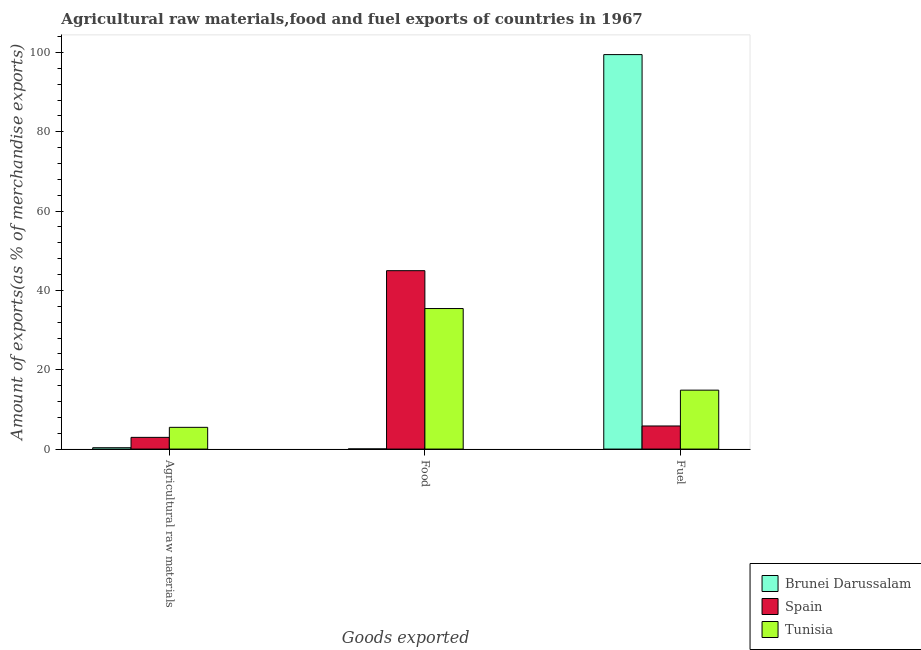How many different coloured bars are there?
Keep it short and to the point. 3. How many groups of bars are there?
Keep it short and to the point. 3. Are the number of bars per tick equal to the number of legend labels?
Your answer should be compact. Yes. How many bars are there on the 3rd tick from the left?
Provide a succinct answer. 3. How many bars are there on the 3rd tick from the right?
Your response must be concise. 3. What is the label of the 1st group of bars from the left?
Provide a succinct answer. Agricultural raw materials. What is the percentage of raw materials exports in Tunisia?
Ensure brevity in your answer.  5.48. Across all countries, what is the maximum percentage of raw materials exports?
Provide a succinct answer. 5.48. Across all countries, what is the minimum percentage of raw materials exports?
Ensure brevity in your answer.  0.34. In which country was the percentage of fuel exports maximum?
Offer a very short reply. Brunei Darussalam. What is the total percentage of raw materials exports in the graph?
Make the answer very short. 8.78. What is the difference between the percentage of raw materials exports in Spain and that in Tunisia?
Make the answer very short. -2.53. What is the difference between the percentage of fuel exports in Brunei Darussalam and the percentage of raw materials exports in Tunisia?
Your response must be concise. 93.98. What is the average percentage of raw materials exports per country?
Make the answer very short. 2.93. What is the difference between the percentage of raw materials exports and percentage of fuel exports in Spain?
Provide a short and direct response. -2.87. What is the ratio of the percentage of fuel exports in Brunei Darussalam to that in Spain?
Make the answer very short. 17.08. Is the percentage of food exports in Tunisia less than that in Brunei Darussalam?
Your answer should be compact. No. Is the difference between the percentage of raw materials exports in Spain and Brunei Darussalam greater than the difference between the percentage of fuel exports in Spain and Brunei Darussalam?
Ensure brevity in your answer.  Yes. What is the difference between the highest and the second highest percentage of fuel exports?
Your answer should be compact. 84.6. What is the difference between the highest and the lowest percentage of food exports?
Keep it short and to the point. 44.94. In how many countries, is the percentage of food exports greater than the average percentage of food exports taken over all countries?
Provide a short and direct response. 2. Is it the case that in every country, the sum of the percentage of raw materials exports and percentage of food exports is greater than the percentage of fuel exports?
Keep it short and to the point. No. How many bars are there?
Your answer should be very brief. 9. How many countries are there in the graph?
Keep it short and to the point. 3. What is the difference between two consecutive major ticks on the Y-axis?
Offer a terse response. 20. Are the values on the major ticks of Y-axis written in scientific E-notation?
Your answer should be very brief. No. Does the graph contain grids?
Keep it short and to the point. No. How many legend labels are there?
Provide a succinct answer. 3. What is the title of the graph?
Keep it short and to the point. Agricultural raw materials,food and fuel exports of countries in 1967. Does "Cyprus" appear as one of the legend labels in the graph?
Ensure brevity in your answer.  No. What is the label or title of the X-axis?
Provide a short and direct response. Goods exported. What is the label or title of the Y-axis?
Make the answer very short. Amount of exports(as % of merchandise exports). What is the Amount of exports(as % of merchandise exports) of Brunei Darussalam in Agricultural raw materials?
Keep it short and to the point. 0.34. What is the Amount of exports(as % of merchandise exports) in Spain in Agricultural raw materials?
Offer a terse response. 2.95. What is the Amount of exports(as % of merchandise exports) of Tunisia in Agricultural raw materials?
Your answer should be very brief. 5.48. What is the Amount of exports(as % of merchandise exports) in Brunei Darussalam in Food?
Keep it short and to the point. 0.04. What is the Amount of exports(as % of merchandise exports) in Spain in Food?
Offer a terse response. 44.98. What is the Amount of exports(as % of merchandise exports) in Tunisia in Food?
Your answer should be compact. 35.43. What is the Amount of exports(as % of merchandise exports) of Brunei Darussalam in Fuel?
Keep it short and to the point. 99.46. What is the Amount of exports(as % of merchandise exports) in Spain in Fuel?
Make the answer very short. 5.82. What is the Amount of exports(as % of merchandise exports) in Tunisia in Fuel?
Give a very brief answer. 14.86. Across all Goods exported, what is the maximum Amount of exports(as % of merchandise exports) in Brunei Darussalam?
Give a very brief answer. 99.46. Across all Goods exported, what is the maximum Amount of exports(as % of merchandise exports) of Spain?
Offer a very short reply. 44.98. Across all Goods exported, what is the maximum Amount of exports(as % of merchandise exports) of Tunisia?
Your answer should be very brief. 35.43. Across all Goods exported, what is the minimum Amount of exports(as % of merchandise exports) in Brunei Darussalam?
Provide a succinct answer. 0.04. Across all Goods exported, what is the minimum Amount of exports(as % of merchandise exports) in Spain?
Offer a terse response. 2.95. Across all Goods exported, what is the minimum Amount of exports(as % of merchandise exports) of Tunisia?
Give a very brief answer. 5.48. What is the total Amount of exports(as % of merchandise exports) of Brunei Darussalam in the graph?
Offer a very short reply. 99.84. What is the total Amount of exports(as % of merchandise exports) in Spain in the graph?
Ensure brevity in your answer.  53.76. What is the total Amount of exports(as % of merchandise exports) in Tunisia in the graph?
Your answer should be very brief. 55.77. What is the difference between the Amount of exports(as % of merchandise exports) of Brunei Darussalam in Agricultural raw materials and that in Food?
Your response must be concise. 0.31. What is the difference between the Amount of exports(as % of merchandise exports) in Spain in Agricultural raw materials and that in Food?
Keep it short and to the point. -42.03. What is the difference between the Amount of exports(as % of merchandise exports) in Tunisia in Agricultural raw materials and that in Food?
Offer a terse response. -29.95. What is the difference between the Amount of exports(as % of merchandise exports) in Brunei Darussalam in Agricultural raw materials and that in Fuel?
Offer a terse response. -99.11. What is the difference between the Amount of exports(as % of merchandise exports) in Spain in Agricultural raw materials and that in Fuel?
Provide a succinct answer. -2.87. What is the difference between the Amount of exports(as % of merchandise exports) in Tunisia in Agricultural raw materials and that in Fuel?
Provide a short and direct response. -9.38. What is the difference between the Amount of exports(as % of merchandise exports) of Brunei Darussalam in Food and that in Fuel?
Offer a terse response. -99.42. What is the difference between the Amount of exports(as % of merchandise exports) in Spain in Food and that in Fuel?
Offer a terse response. 39.16. What is the difference between the Amount of exports(as % of merchandise exports) of Tunisia in Food and that in Fuel?
Ensure brevity in your answer.  20.57. What is the difference between the Amount of exports(as % of merchandise exports) in Brunei Darussalam in Agricultural raw materials and the Amount of exports(as % of merchandise exports) in Spain in Food?
Offer a terse response. -44.64. What is the difference between the Amount of exports(as % of merchandise exports) in Brunei Darussalam in Agricultural raw materials and the Amount of exports(as % of merchandise exports) in Tunisia in Food?
Provide a short and direct response. -35.09. What is the difference between the Amount of exports(as % of merchandise exports) in Spain in Agricultural raw materials and the Amount of exports(as % of merchandise exports) in Tunisia in Food?
Give a very brief answer. -32.48. What is the difference between the Amount of exports(as % of merchandise exports) in Brunei Darussalam in Agricultural raw materials and the Amount of exports(as % of merchandise exports) in Spain in Fuel?
Keep it short and to the point. -5.48. What is the difference between the Amount of exports(as % of merchandise exports) of Brunei Darussalam in Agricultural raw materials and the Amount of exports(as % of merchandise exports) of Tunisia in Fuel?
Your answer should be compact. -14.51. What is the difference between the Amount of exports(as % of merchandise exports) of Spain in Agricultural raw materials and the Amount of exports(as % of merchandise exports) of Tunisia in Fuel?
Your answer should be compact. -11.91. What is the difference between the Amount of exports(as % of merchandise exports) in Brunei Darussalam in Food and the Amount of exports(as % of merchandise exports) in Spain in Fuel?
Ensure brevity in your answer.  -5.78. What is the difference between the Amount of exports(as % of merchandise exports) of Brunei Darussalam in Food and the Amount of exports(as % of merchandise exports) of Tunisia in Fuel?
Give a very brief answer. -14.82. What is the difference between the Amount of exports(as % of merchandise exports) of Spain in Food and the Amount of exports(as % of merchandise exports) of Tunisia in Fuel?
Your response must be concise. 30.12. What is the average Amount of exports(as % of merchandise exports) of Brunei Darussalam per Goods exported?
Your answer should be very brief. 33.28. What is the average Amount of exports(as % of merchandise exports) in Spain per Goods exported?
Offer a very short reply. 17.92. What is the average Amount of exports(as % of merchandise exports) of Tunisia per Goods exported?
Ensure brevity in your answer.  18.59. What is the difference between the Amount of exports(as % of merchandise exports) of Brunei Darussalam and Amount of exports(as % of merchandise exports) of Spain in Agricultural raw materials?
Keep it short and to the point. -2.61. What is the difference between the Amount of exports(as % of merchandise exports) in Brunei Darussalam and Amount of exports(as % of merchandise exports) in Tunisia in Agricultural raw materials?
Keep it short and to the point. -5.14. What is the difference between the Amount of exports(as % of merchandise exports) of Spain and Amount of exports(as % of merchandise exports) of Tunisia in Agricultural raw materials?
Give a very brief answer. -2.53. What is the difference between the Amount of exports(as % of merchandise exports) of Brunei Darussalam and Amount of exports(as % of merchandise exports) of Spain in Food?
Make the answer very short. -44.94. What is the difference between the Amount of exports(as % of merchandise exports) in Brunei Darussalam and Amount of exports(as % of merchandise exports) in Tunisia in Food?
Provide a succinct answer. -35.39. What is the difference between the Amount of exports(as % of merchandise exports) in Spain and Amount of exports(as % of merchandise exports) in Tunisia in Food?
Give a very brief answer. 9.55. What is the difference between the Amount of exports(as % of merchandise exports) of Brunei Darussalam and Amount of exports(as % of merchandise exports) of Spain in Fuel?
Offer a very short reply. 93.64. What is the difference between the Amount of exports(as % of merchandise exports) of Brunei Darussalam and Amount of exports(as % of merchandise exports) of Tunisia in Fuel?
Keep it short and to the point. 84.6. What is the difference between the Amount of exports(as % of merchandise exports) in Spain and Amount of exports(as % of merchandise exports) in Tunisia in Fuel?
Offer a very short reply. -9.04. What is the ratio of the Amount of exports(as % of merchandise exports) in Brunei Darussalam in Agricultural raw materials to that in Food?
Offer a terse response. 8.85. What is the ratio of the Amount of exports(as % of merchandise exports) in Spain in Agricultural raw materials to that in Food?
Offer a terse response. 0.07. What is the ratio of the Amount of exports(as % of merchandise exports) in Tunisia in Agricultural raw materials to that in Food?
Provide a succinct answer. 0.15. What is the ratio of the Amount of exports(as % of merchandise exports) in Brunei Darussalam in Agricultural raw materials to that in Fuel?
Ensure brevity in your answer.  0. What is the ratio of the Amount of exports(as % of merchandise exports) of Spain in Agricultural raw materials to that in Fuel?
Keep it short and to the point. 0.51. What is the ratio of the Amount of exports(as % of merchandise exports) in Tunisia in Agricultural raw materials to that in Fuel?
Offer a very short reply. 0.37. What is the ratio of the Amount of exports(as % of merchandise exports) in Brunei Darussalam in Food to that in Fuel?
Provide a short and direct response. 0. What is the ratio of the Amount of exports(as % of merchandise exports) in Spain in Food to that in Fuel?
Ensure brevity in your answer.  7.72. What is the ratio of the Amount of exports(as % of merchandise exports) in Tunisia in Food to that in Fuel?
Provide a succinct answer. 2.38. What is the difference between the highest and the second highest Amount of exports(as % of merchandise exports) in Brunei Darussalam?
Ensure brevity in your answer.  99.11. What is the difference between the highest and the second highest Amount of exports(as % of merchandise exports) of Spain?
Offer a terse response. 39.16. What is the difference between the highest and the second highest Amount of exports(as % of merchandise exports) in Tunisia?
Give a very brief answer. 20.57. What is the difference between the highest and the lowest Amount of exports(as % of merchandise exports) of Brunei Darussalam?
Keep it short and to the point. 99.42. What is the difference between the highest and the lowest Amount of exports(as % of merchandise exports) in Spain?
Offer a terse response. 42.03. What is the difference between the highest and the lowest Amount of exports(as % of merchandise exports) in Tunisia?
Provide a succinct answer. 29.95. 